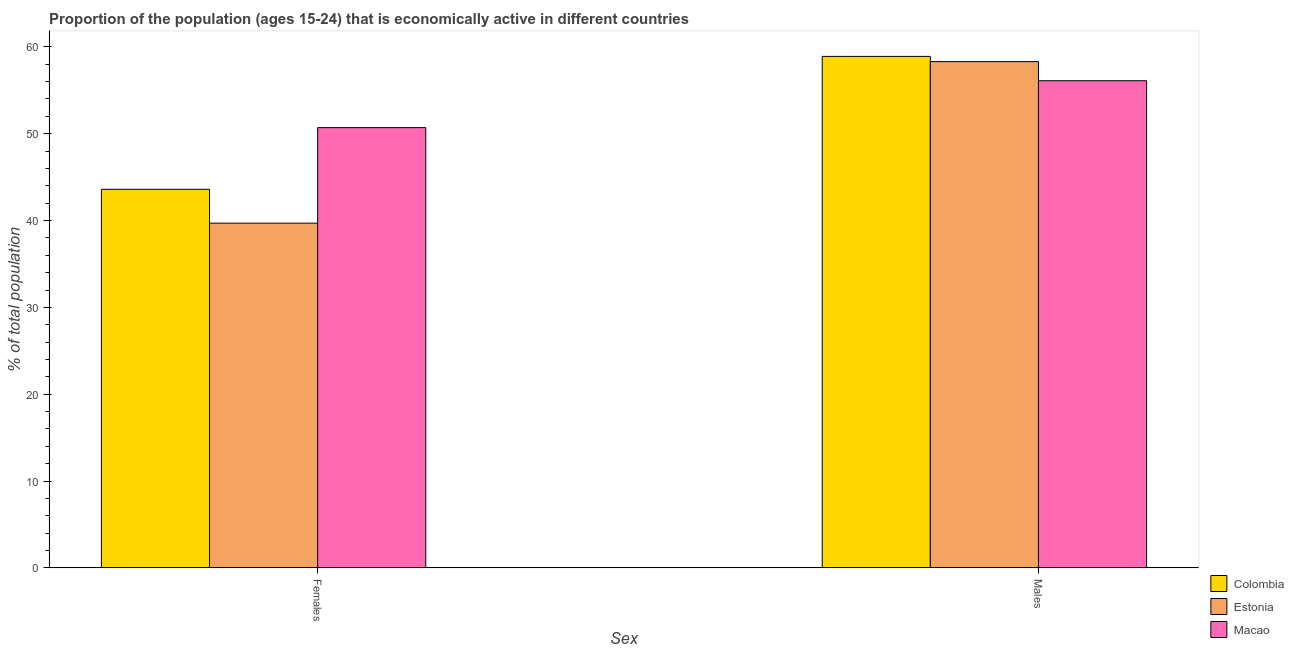Are the number of bars per tick equal to the number of legend labels?
Make the answer very short. Yes. Are the number of bars on each tick of the X-axis equal?
Provide a succinct answer. Yes. What is the label of the 2nd group of bars from the left?
Make the answer very short. Males. What is the percentage of economically active female population in Colombia?
Your answer should be very brief. 43.6. Across all countries, what is the maximum percentage of economically active male population?
Offer a terse response. 58.9. Across all countries, what is the minimum percentage of economically active male population?
Keep it short and to the point. 56.1. In which country was the percentage of economically active female population maximum?
Keep it short and to the point. Macao. In which country was the percentage of economically active female population minimum?
Make the answer very short. Estonia. What is the total percentage of economically active female population in the graph?
Your response must be concise. 134. What is the difference between the percentage of economically active female population in Estonia and that in Colombia?
Your answer should be very brief. -3.9. What is the difference between the percentage of economically active female population in Estonia and the percentage of economically active male population in Macao?
Make the answer very short. -16.4. What is the average percentage of economically active male population per country?
Provide a short and direct response. 57.77. What is the difference between the percentage of economically active male population and percentage of economically active female population in Estonia?
Your response must be concise. 18.6. What is the ratio of the percentage of economically active female population in Macao to that in Estonia?
Make the answer very short. 1.28. Is the percentage of economically active female population in Colombia less than that in Macao?
Your answer should be very brief. Yes. In how many countries, is the percentage of economically active male population greater than the average percentage of economically active male population taken over all countries?
Provide a succinct answer. 2. What does the 2nd bar from the right in Males represents?
Your answer should be compact. Estonia. Are all the bars in the graph horizontal?
Your response must be concise. No. How many countries are there in the graph?
Provide a succinct answer. 3. What is the difference between two consecutive major ticks on the Y-axis?
Ensure brevity in your answer.  10. Does the graph contain any zero values?
Your answer should be very brief. No. Does the graph contain grids?
Your answer should be compact. No. How many legend labels are there?
Provide a short and direct response. 3. What is the title of the graph?
Your response must be concise. Proportion of the population (ages 15-24) that is economically active in different countries. Does "Uruguay" appear as one of the legend labels in the graph?
Provide a succinct answer. No. What is the label or title of the X-axis?
Keep it short and to the point. Sex. What is the label or title of the Y-axis?
Make the answer very short. % of total population. What is the % of total population in Colombia in Females?
Provide a succinct answer. 43.6. What is the % of total population of Estonia in Females?
Your answer should be compact. 39.7. What is the % of total population of Macao in Females?
Give a very brief answer. 50.7. What is the % of total population in Colombia in Males?
Your answer should be compact. 58.9. What is the % of total population of Estonia in Males?
Offer a terse response. 58.3. What is the % of total population of Macao in Males?
Provide a short and direct response. 56.1. Across all Sex, what is the maximum % of total population of Colombia?
Your answer should be compact. 58.9. Across all Sex, what is the maximum % of total population of Estonia?
Keep it short and to the point. 58.3. Across all Sex, what is the maximum % of total population in Macao?
Offer a terse response. 56.1. Across all Sex, what is the minimum % of total population of Colombia?
Offer a terse response. 43.6. Across all Sex, what is the minimum % of total population of Estonia?
Ensure brevity in your answer.  39.7. Across all Sex, what is the minimum % of total population in Macao?
Give a very brief answer. 50.7. What is the total % of total population of Colombia in the graph?
Ensure brevity in your answer.  102.5. What is the total % of total population of Estonia in the graph?
Offer a terse response. 98. What is the total % of total population of Macao in the graph?
Your answer should be compact. 106.8. What is the difference between the % of total population of Colombia in Females and that in Males?
Offer a very short reply. -15.3. What is the difference between the % of total population of Estonia in Females and that in Males?
Provide a succinct answer. -18.6. What is the difference between the % of total population in Macao in Females and that in Males?
Offer a terse response. -5.4. What is the difference between the % of total population of Colombia in Females and the % of total population of Estonia in Males?
Make the answer very short. -14.7. What is the difference between the % of total population in Colombia in Females and the % of total population in Macao in Males?
Provide a short and direct response. -12.5. What is the difference between the % of total population in Estonia in Females and the % of total population in Macao in Males?
Ensure brevity in your answer.  -16.4. What is the average % of total population in Colombia per Sex?
Offer a terse response. 51.25. What is the average % of total population in Macao per Sex?
Provide a short and direct response. 53.4. What is the difference between the % of total population in Colombia and % of total population in Estonia in Females?
Make the answer very short. 3.9. What is the difference between the % of total population of Estonia and % of total population of Macao in Females?
Provide a succinct answer. -11. What is the ratio of the % of total population of Colombia in Females to that in Males?
Offer a terse response. 0.74. What is the ratio of the % of total population in Estonia in Females to that in Males?
Give a very brief answer. 0.68. What is the ratio of the % of total population in Macao in Females to that in Males?
Make the answer very short. 0.9. What is the difference between the highest and the second highest % of total population of Estonia?
Keep it short and to the point. 18.6. What is the difference between the highest and the second highest % of total population of Macao?
Your answer should be compact. 5.4. What is the difference between the highest and the lowest % of total population of Colombia?
Provide a succinct answer. 15.3. What is the difference between the highest and the lowest % of total population in Macao?
Ensure brevity in your answer.  5.4. 